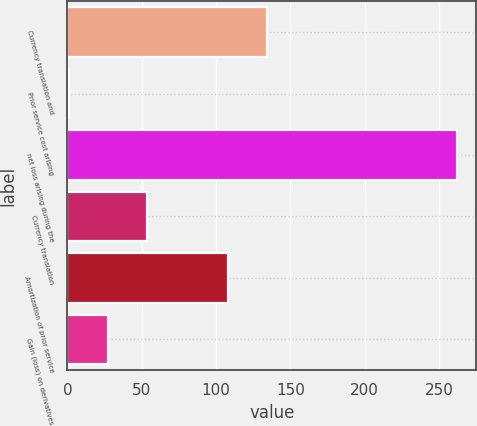<chart> <loc_0><loc_0><loc_500><loc_500><bar_chart><fcel>Currency translation and<fcel>Prior service cost arising<fcel>net loss arising during the<fcel>Currency translation<fcel>Amortization of prior service<fcel>Gain (loss) on derivatives<nl><fcel>134.1<fcel>1<fcel>262<fcel>53.2<fcel>108<fcel>27.1<nl></chart> 